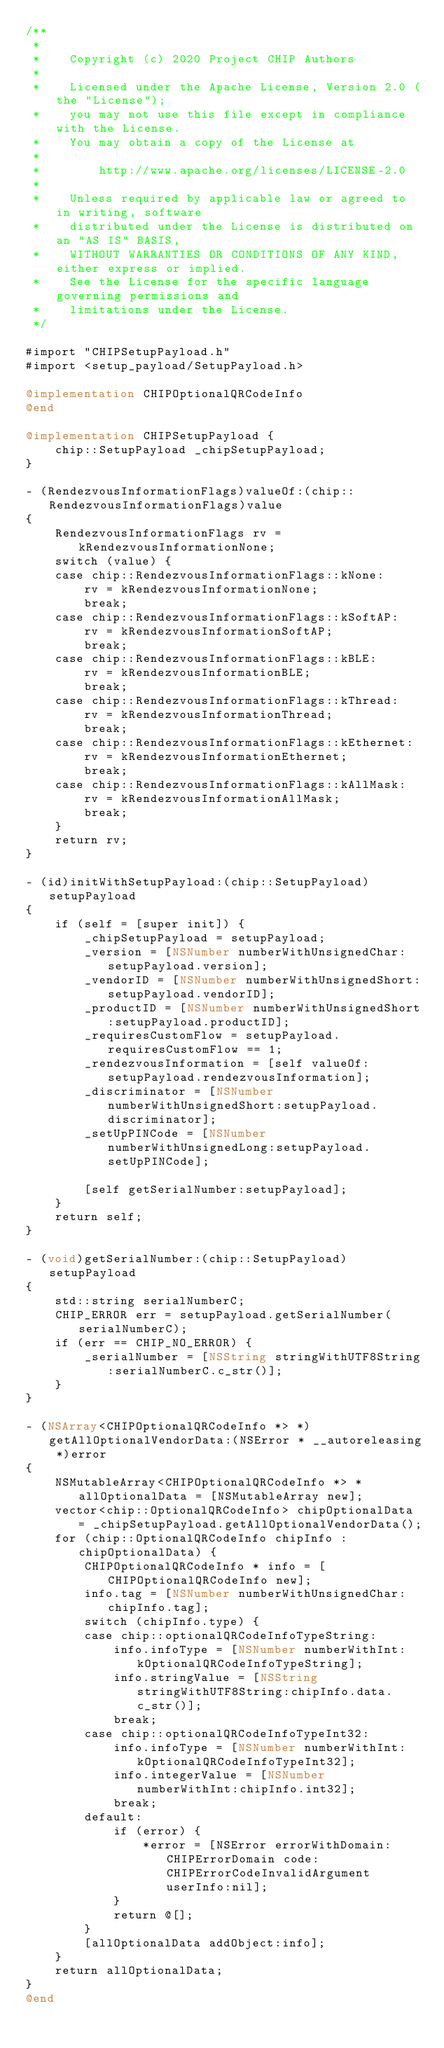Convert code to text. <code><loc_0><loc_0><loc_500><loc_500><_ObjectiveC_>/**
 *
 *    Copyright (c) 2020 Project CHIP Authors
 *
 *    Licensed under the Apache License, Version 2.0 (the "License");
 *    you may not use this file except in compliance with the License.
 *    You may obtain a copy of the License at
 *
 *        http://www.apache.org/licenses/LICENSE-2.0
 *
 *    Unless required by applicable law or agreed to in writing, software
 *    distributed under the License is distributed on an "AS IS" BASIS,
 *    WITHOUT WARRANTIES OR CONDITIONS OF ANY KIND, either express or implied.
 *    See the License for the specific language governing permissions and
 *    limitations under the License.
 */

#import "CHIPSetupPayload.h"
#import <setup_payload/SetupPayload.h>

@implementation CHIPOptionalQRCodeInfo
@end

@implementation CHIPSetupPayload {
    chip::SetupPayload _chipSetupPayload;
}

- (RendezvousInformationFlags)valueOf:(chip::RendezvousInformationFlags)value
{
    RendezvousInformationFlags rv = kRendezvousInformationNone;
    switch (value) {
    case chip::RendezvousInformationFlags::kNone:
        rv = kRendezvousInformationNone;
        break;
    case chip::RendezvousInformationFlags::kSoftAP:
        rv = kRendezvousInformationSoftAP;
        break;
    case chip::RendezvousInformationFlags::kBLE:
        rv = kRendezvousInformationBLE;
        break;
    case chip::RendezvousInformationFlags::kThread:
        rv = kRendezvousInformationThread;
        break;
    case chip::RendezvousInformationFlags::kEthernet:
        rv = kRendezvousInformationEthernet;
        break;
    case chip::RendezvousInformationFlags::kAllMask:
        rv = kRendezvousInformationAllMask;
        break;
    }
    return rv;
}

- (id)initWithSetupPayload:(chip::SetupPayload)setupPayload
{
    if (self = [super init]) {
        _chipSetupPayload = setupPayload;
        _version = [NSNumber numberWithUnsignedChar:setupPayload.version];
        _vendorID = [NSNumber numberWithUnsignedShort:setupPayload.vendorID];
        _productID = [NSNumber numberWithUnsignedShort:setupPayload.productID];
        _requiresCustomFlow = setupPayload.requiresCustomFlow == 1;
        _rendezvousInformation = [self valueOf:setupPayload.rendezvousInformation];
        _discriminator = [NSNumber numberWithUnsignedShort:setupPayload.discriminator];
        _setUpPINCode = [NSNumber numberWithUnsignedLong:setupPayload.setUpPINCode];

        [self getSerialNumber:setupPayload];
    }
    return self;
}

- (void)getSerialNumber:(chip::SetupPayload)setupPayload
{
    std::string serialNumberC;
    CHIP_ERROR err = setupPayload.getSerialNumber(serialNumberC);
    if (err == CHIP_NO_ERROR) {
        _serialNumber = [NSString stringWithUTF8String:serialNumberC.c_str()];
    }
}

- (NSArray<CHIPOptionalQRCodeInfo *> *)getAllOptionalVendorData:(NSError * __autoreleasing *)error
{
    NSMutableArray<CHIPOptionalQRCodeInfo *> * allOptionalData = [NSMutableArray new];
    vector<chip::OptionalQRCodeInfo> chipOptionalData = _chipSetupPayload.getAllOptionalVendorData();
    for (chip::OptionalQRCodeInfo chipInfo : chipOptionalData) {
        CHIPOptionalQRCodeInfo * info = [CHIPOptionalQRCodeInfo new];
        info.tag = [NSNumber numberWithUnsignedChar:chipInfo.tag];
        switch (chipInfo.type) {
        case chip::optionalQRCodeInfoTypeString:
            info.infoType = [NSNumber numberWithInt:kOptionalQRCodeInfoTypeString];
            info.stringValue = [NSString stringWithUTF8String:chipInfo.data.c_str()];
            break;
        case chip::optionalQRCodeInfoTypeInt32:
            info.infoType = [NSNumber numberWithInt:kOptionalQRCodeInfoTypeInt32];
            info.integerValue = [NSNumber numberWithInt:chipInfo.int32];
            break;
        default:
            if (error) {
                *error = [NSError errorWithDomain:CHIPErrorDomain code:CHIPErrorCodeInvalidArgument userInfo:nil];
            }
            return @[];
        }
        [allOptionalData addObject:info];
    }
    return allOptionalData;
}
@end
</code> 